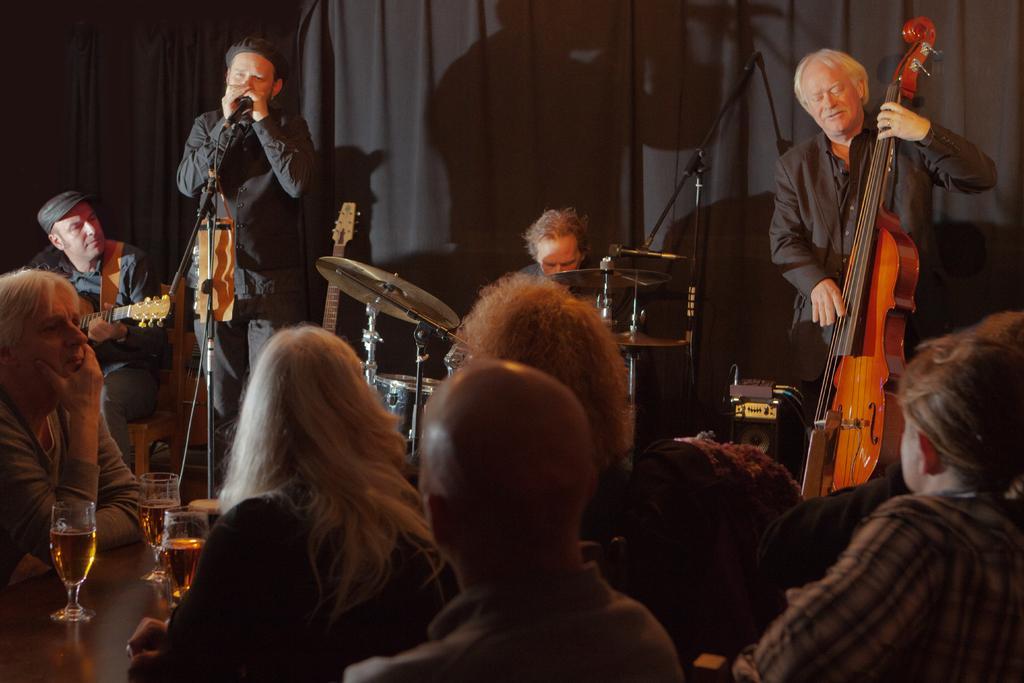Describe this image in one or two sentences. There is a music band on the side of a room. Four members are playing four different kinds of instruments. Behind them, there is a black curtain in the background. In front of them, there are some people watching and enjoying their performance, sitting in the chairs. In front of them there are some glasses with some drink on the table. 